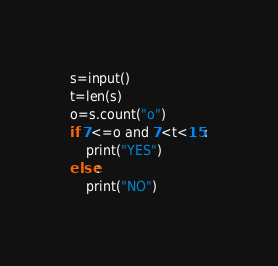Convert code to text. <code><loc_0><loc_0><loc_500><loc_500><_Python_>s=input()
t=len(s)
o=s.count("o")
if 7<=o and 7<t<15:
    print("YES")
else:
    print("NO")</code> 